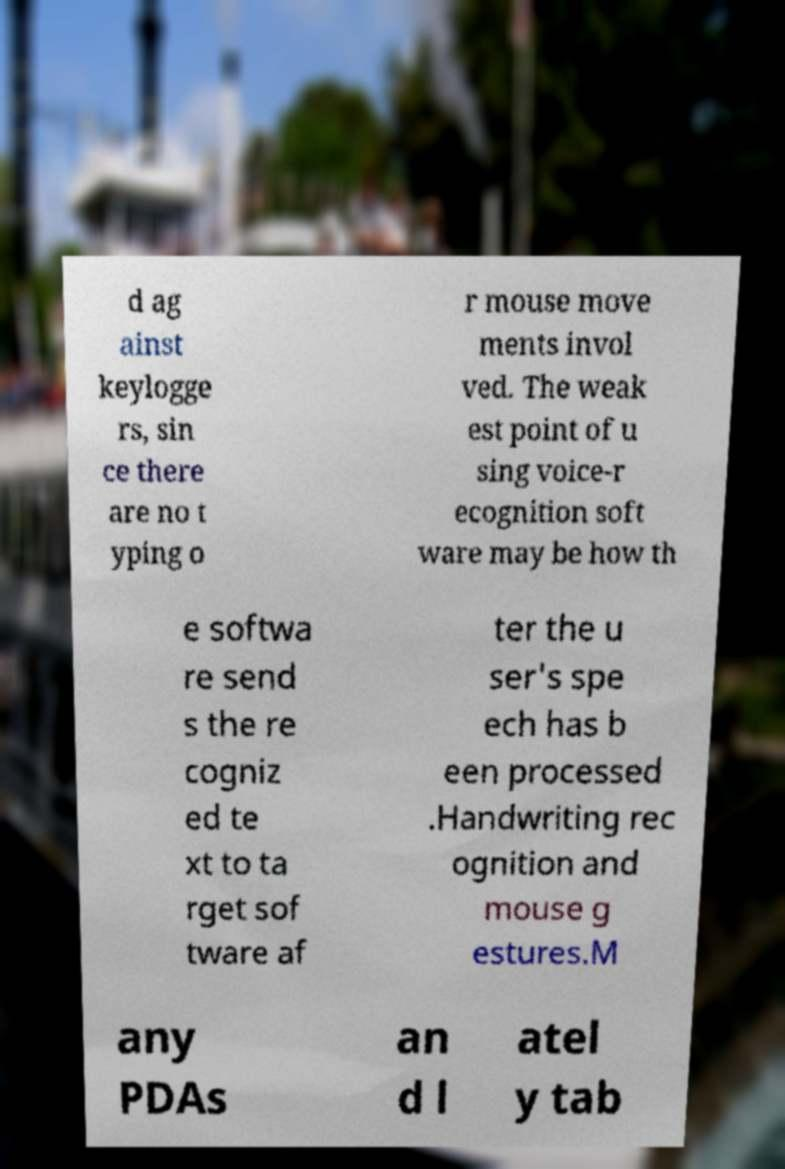I need the written content from this picture converted into text. Can you do that? d ag ainst keylogge rs, sin ce there are no t yping o r mouse move ments invol ved. The weak est point of u sing voice-r ecognition soft ware may be how th e softwa re send s the re cogniz ed te xt to ta rget sof tware af ter the u ser's spe ech has b een processed .Handwriting rec ognition and mouse g estures.M any PDAs an d l atel y tab 